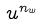<formula> <loc_0><loc_0><loc_500><loc_500>u ^ { n _ { w } }</formula> 